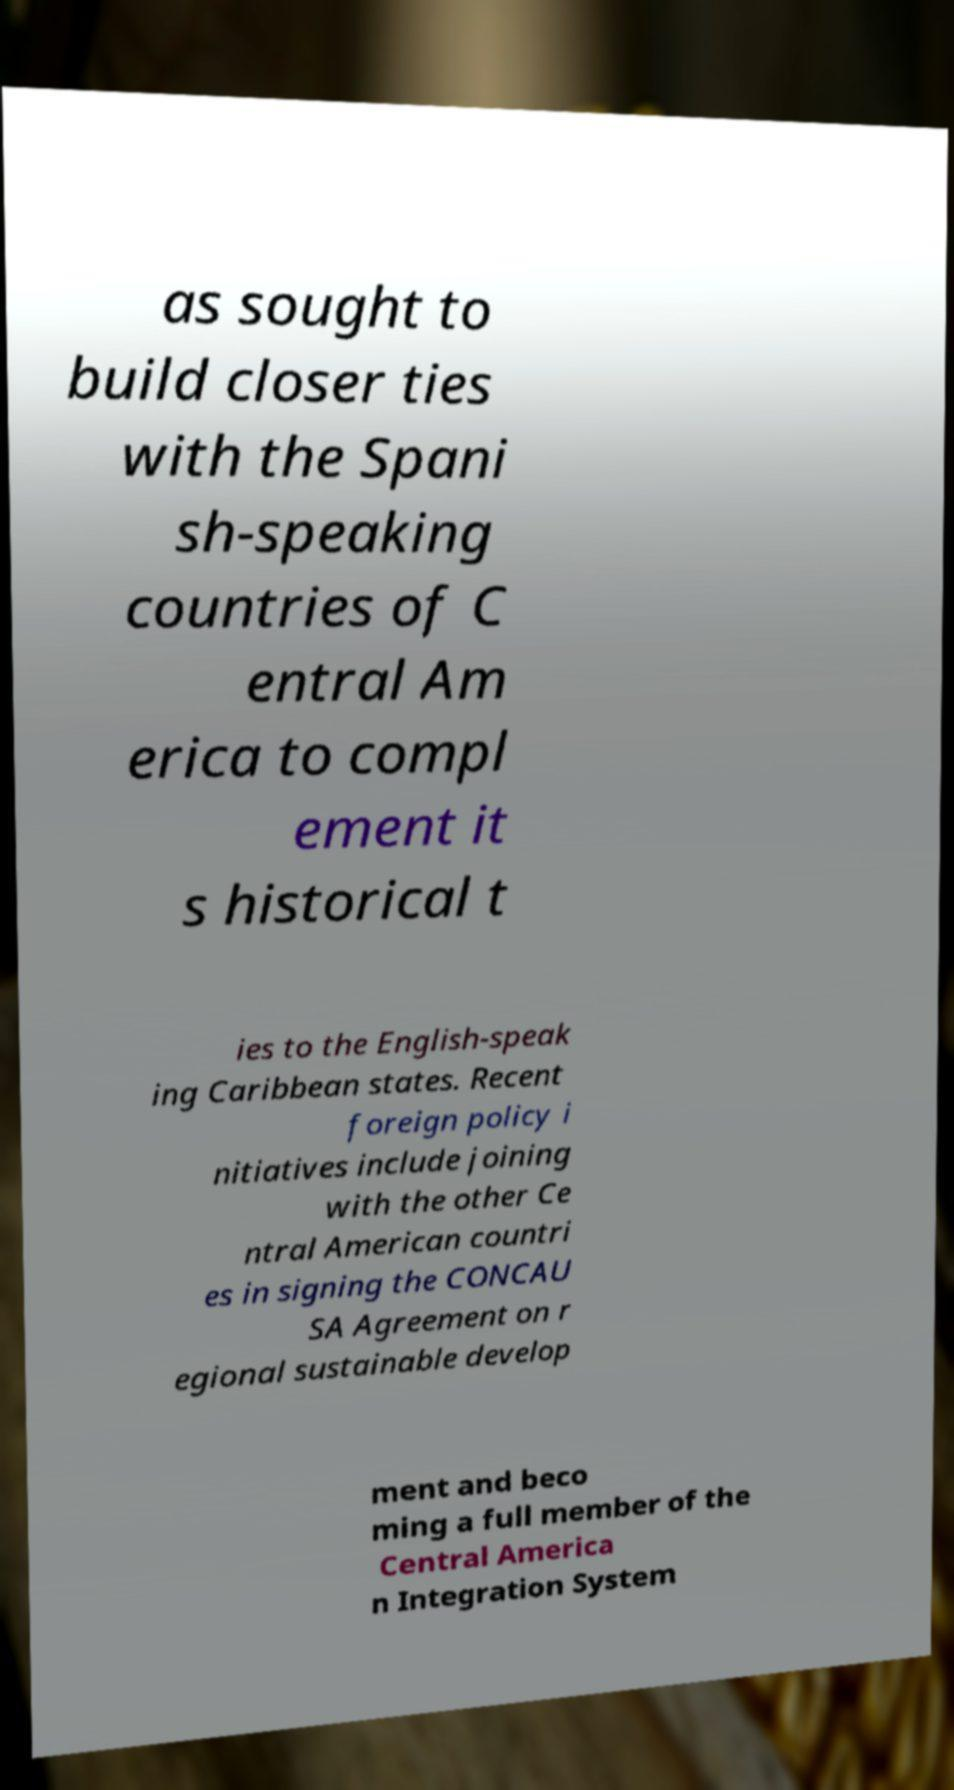Please identify and transcribe the text found in this image. as sought to build closer ties with the Spani sh-speaking countries of C entral Am erica to compl ement it s historical t ies to the English-speak ing Caribbean states. Recent foreign policy i nitiatives include joining with the other Ce ntral American countri es in signing the CONCAU SA Agreement on r egional sustainable develop ment and beco ming a full member of the Central America n Integration System 